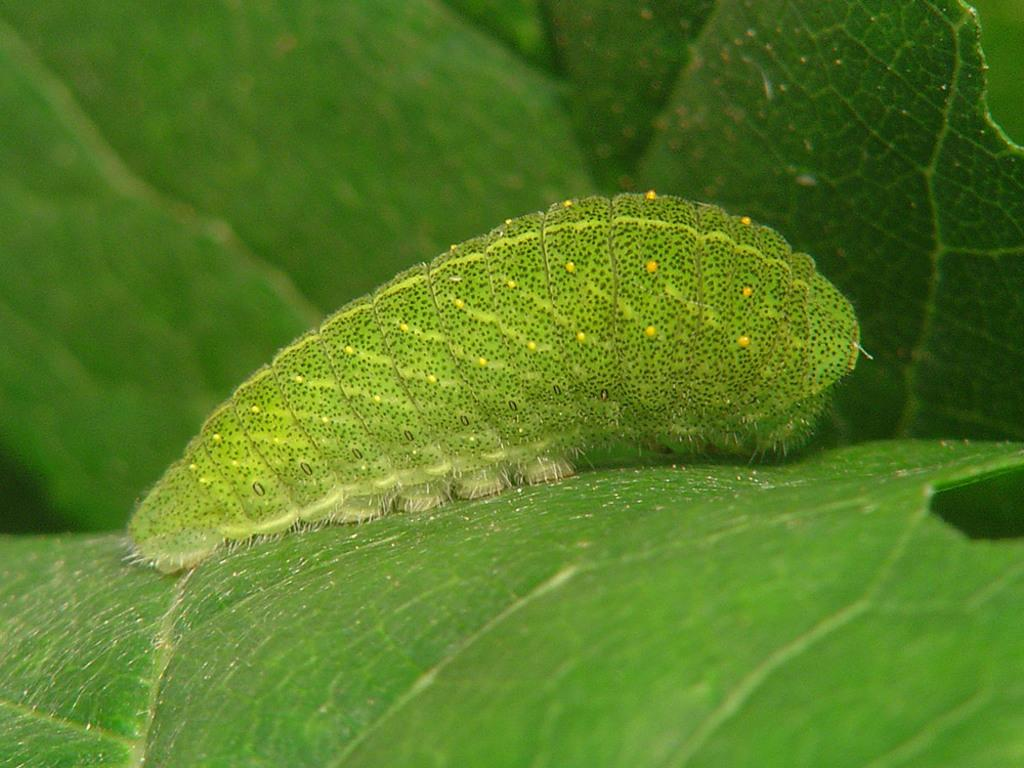What is on the leaf in the image? There is an insect on a leaf in the image. What can be seen in the background of the image? There are leaves visible in the background of the image. What type of education does the woman in the image have? There is no woman present in the image, so it is not possible to determine her level of education. 